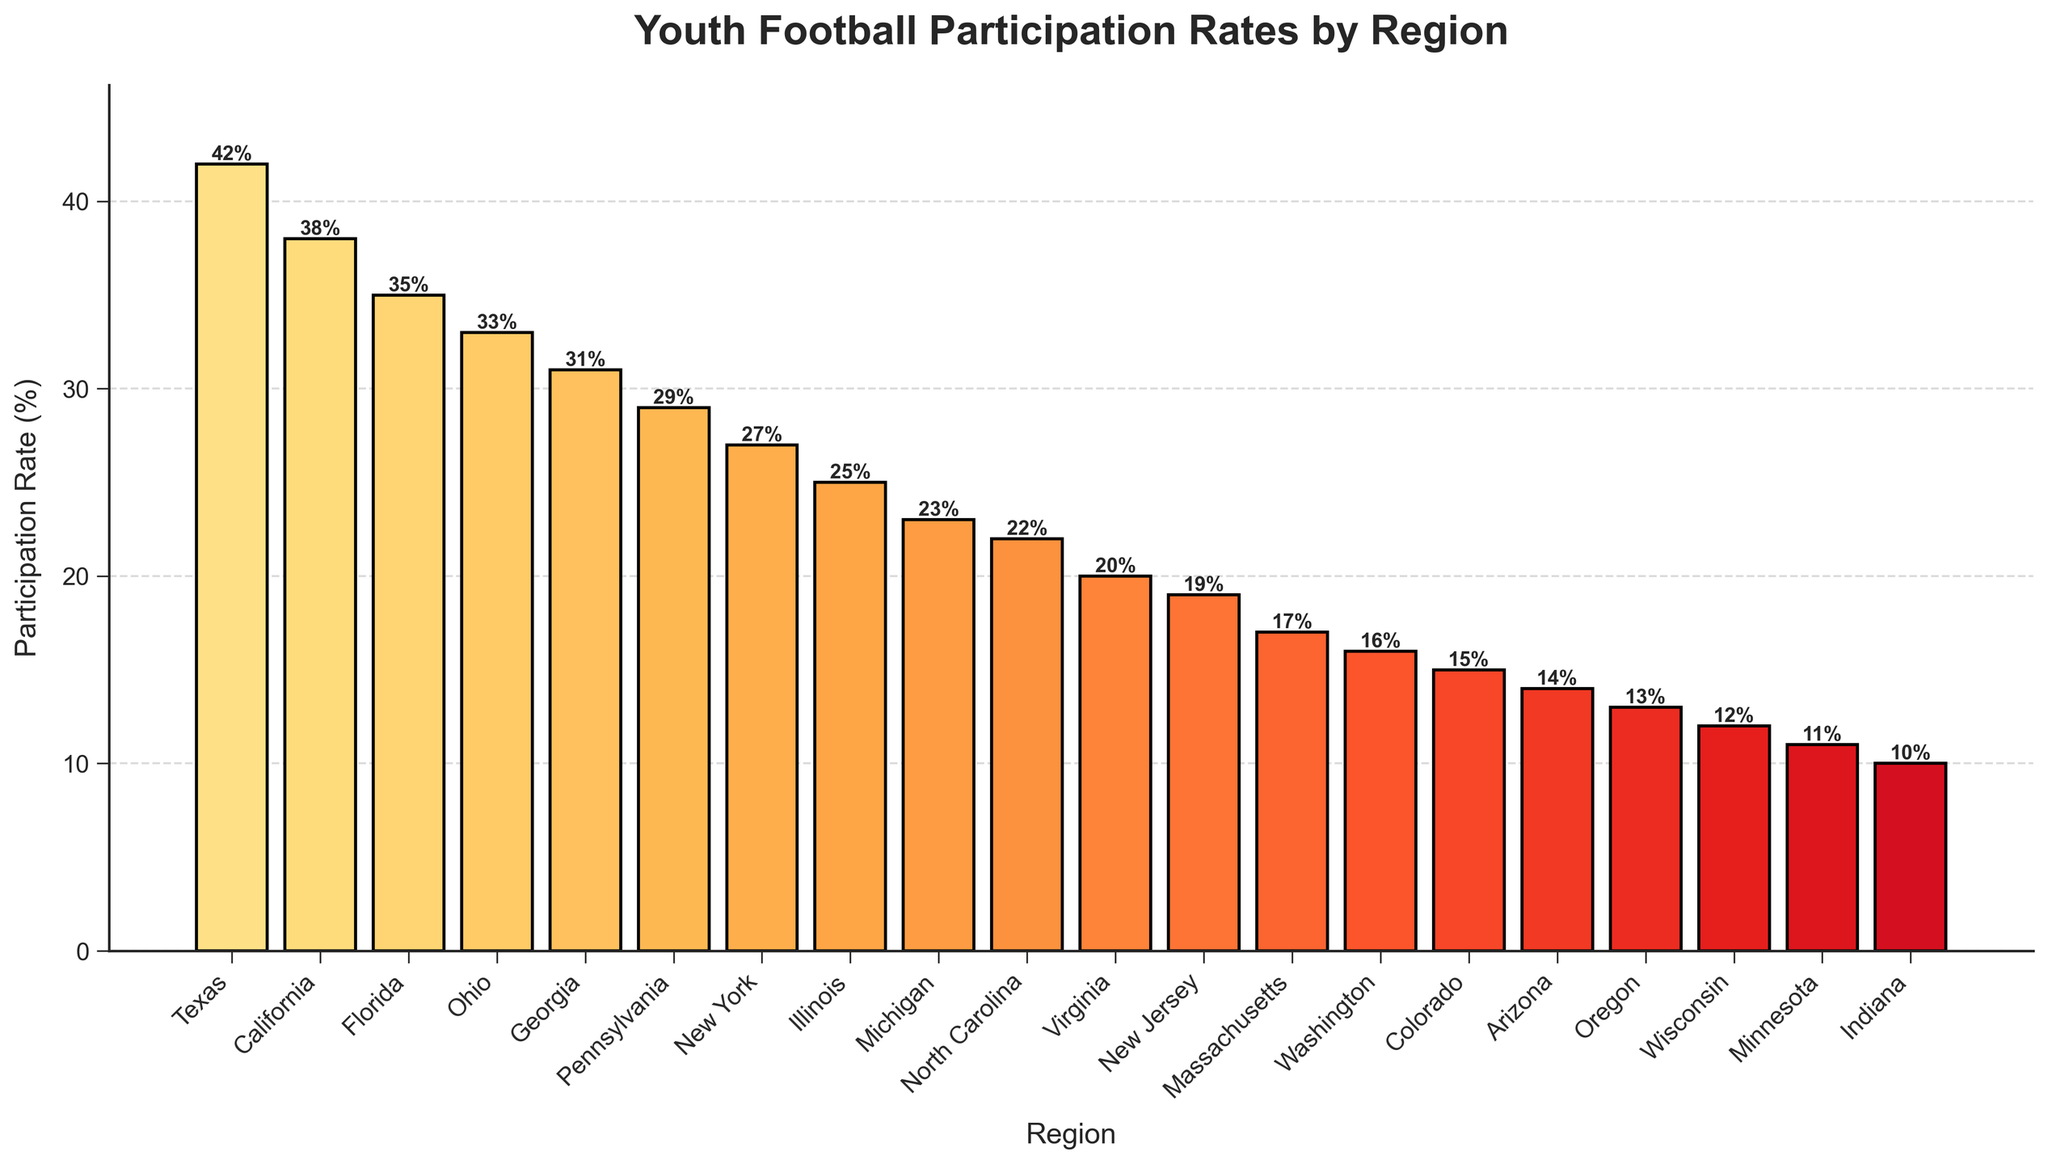What is the participation rate in Texas? Look at the bar labeled "Texas" and refer to the number displayed above it. It shows a participation rate of 42%.
Answer: 42% Compare the participation rates of California and New York. Which is higher and by how much? First, find the participation rates of both California (38%) and New York (27%). Subtract the participation rate of New York from California: 38% - 27% = 11%.
Answer: California by 11% What is the average participation rate of Florida, Ohio, and Georgia combined? Add the participation rates of Florida (35%), Ohio (33%), and Georgia (31%) together and then divide by the number of regions (3). (35 + 33 + 31) / 3 = 33%.
Answer: 33% Which region has the lowest participation rate and what is it? Identify the region with the shortest bar and the smallest number. Indiana has the lowest rate at 10%.
Answer: Indiana with 10% How much greater is the participation rate in Pennsylvania compared to that in Michigan? Find the participation rates of Pennsylvania (29%) and Michigan (23%). Subtract the rate of Michigan from Pennsylvania: 29% - 23% = 6%.
Answer: 6% Considering the regions Illinois, Michigan, and North Carolina, what is their combined participation rate? Add the participation rates of Illinois (25%), Michigan (23%), and North Carolina (22%) together: 25 + 23 + 22 = 70%.
Answer: 70% Which regions have a participation rate of at least 30%? Identify the regions whose bars reach or exceed the 30% mark: Texas (42%), California (38%), Florida (35%), Ohio (33%), and Georgia (31%)
Answer: Texas, California, Florida, Ohio, Georgia Calculate the difference in participation rates between Massachusetts and Virginia. Subtract the participation rate of Massachusetts (17%) from Virginia (20%): 20% - 17% = 3%.
Answer: 3% Which region has a participation rate of 15%, and where is its bar located relative to other bars? Find the bar labeling for "15%", which corresponds to Colorado, and observe its position in the middle range of the chart. It is to the right of the Washington bar and to the left of the Arizona bar.
Answer: Colorado, middle range What is the total participation rate for all regions summed together? Sum all individual participation rates for all regions: 42 + 38 + 35 + 33 + 31 + 29 + 27 + 25 + 23 + 22 + 20 + 19 + 17 + 16 + 15 + 14 + 13 + 12 + 11 + 10 = 439%.
Answer: 439% 